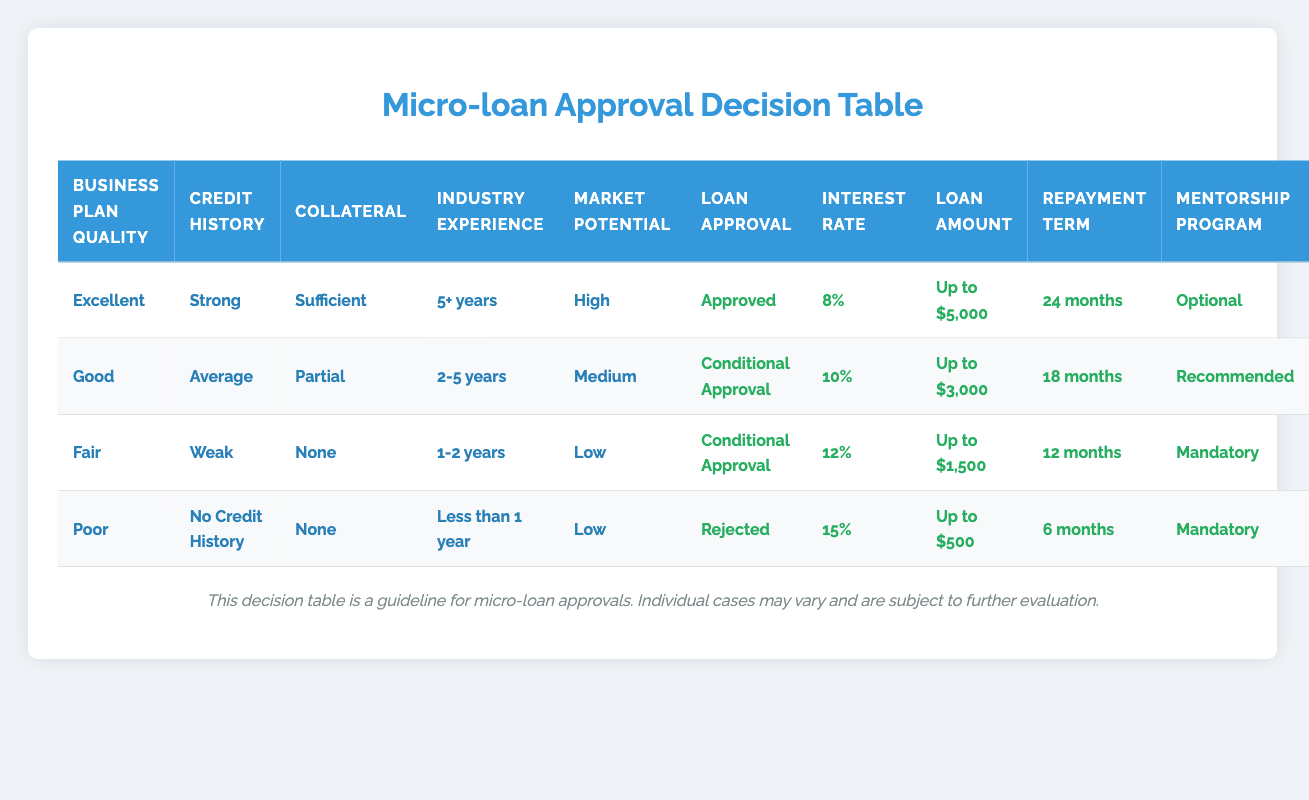What type of loan approval is given for a business with an excellent business plan and strong credit history? According to the table, for a business with "Excellent" business plan quality and "Strong" credit history, the loan approval status is "Approved."
Answer: Approved What is the interest rate for a business applying with weak credit history and no collateral? For a business with "Weak" credit history and "None" for collateral, we look at the row corresponding to "Fair" business plan quality. It shows the interest rate is "12%."
Answer: 12% Is mentorship mandatory for a business with poor market potential? The table states that a business with "Low" market potential and a "Poor" business plan will have a mentorship program that is "Mandatory." Therefore, the answer is yes.
Answer: Yes How many months is the repayment term for a business with good market potential and average credit history? Referring to the row with "Good" business plan quality, "Average" credit history, and "Medium" market potential, the repayment term is "18 months."
Answer: 18 months If a business has two to five years of industry experience, what is the maximum loan amount it can receive? Reviewing the row for "2-5 years" of industry experience with "Good" business plan quality, "Average" credit history, and "Partial" collateral, the maximum loan amount is "Up to $3,000."
Answer: Up to $3,000 What combination of conditions leads to rejection in loan approval? The table indicates that the combination with "Poor" business plan quality, "No Credit History," "None" collateral, "Less than 1 year" industry experience, and "Low" market potential results in the loan being "Rejected." This is a multiple-condition scenario.
Answer: Poor business plan, No credit history, None collateral, Less than 1 year experience, Low market potential Are businesses with high market potential guaranteed loan approval? Looking through the table, not all businesses with "High" market potential are guaranteed approval as it also depends on the quality of the business plan and credit history. For example, a business can still be rejected if it lacks sufficient credit history or collateral.
Answer: No What is the average loan amount across all types of approvals in the table? There are four types of loan amounts: "Up to $5,000," "Up to $3,000," "Up to $1,500," and "Up to $500." We convert these into numerical values for calculation: 5000, 3000, 1500, and 500. Summing these gives 5000 + 3000 + 1500 + 500 = 10000. Dividing by the 4 amounts gives an average of 10000 / 4 = 2500.
Answer: 2500 What interest rate will a business receive if it has a good credit history but only partial collateral? For a business with "Average" credit history and "Partial" collateral mentioned in the "Good" business plan quality row, the interest rate will be "10%."
Answer: 10% 